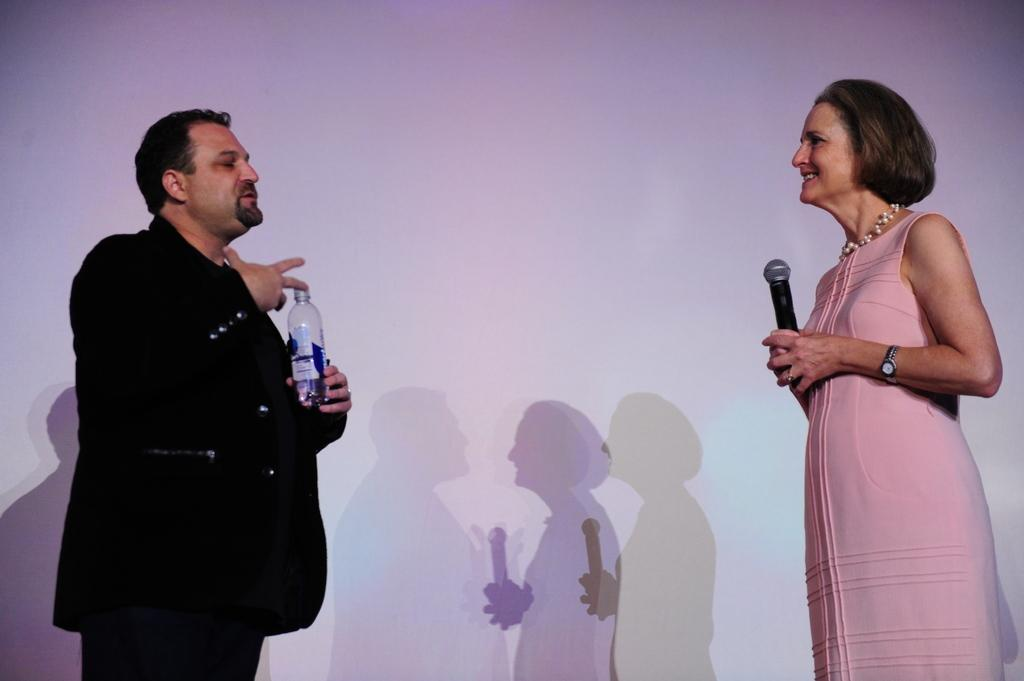What is present in the image that serves as a background? There is a wall in the image that serves as a background. How many people are visible in the image? There are two people standing in the image. What is the man on the right side holding? The man on the right side is holding a mic. What is the man on the left side holding? The man on the left side is holding a bottle. What type of book is the man on the right side reading in the image? There is no book present in the image; the man on the right side is holding a mic. How many oranges are visible on the wall in the image? There are no oranges visible on the wall in the image. 